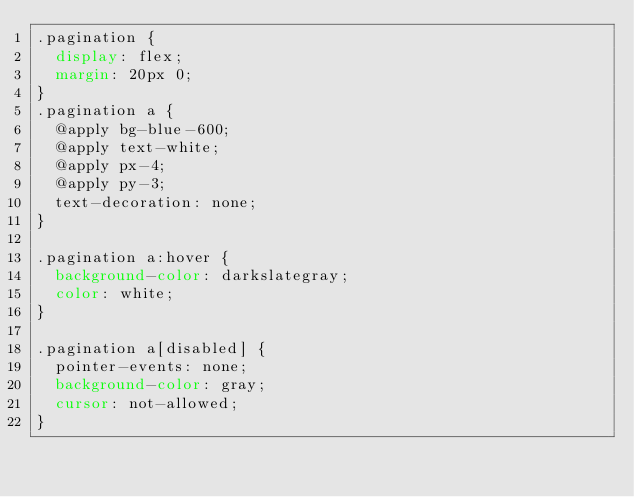Convert code to text. <code><loc_0><loc_0><loc_500><loc_500><_CSS_>.pagination {
  display: flex;
  margin: 20px 0;
}
.pagination a {
  @apply bg-blue-600;
  @apply text-white;
  @apply px-4;
  @apply py-3;
  text-decoration: none;
}

.pagination a:hover {
  background-color: darkslategray;
  color: white;
}

.pagination a[disabled] {
  pointer-events: none;
  background-color: gray;
  cursor: not-allowed;
}
</code> 